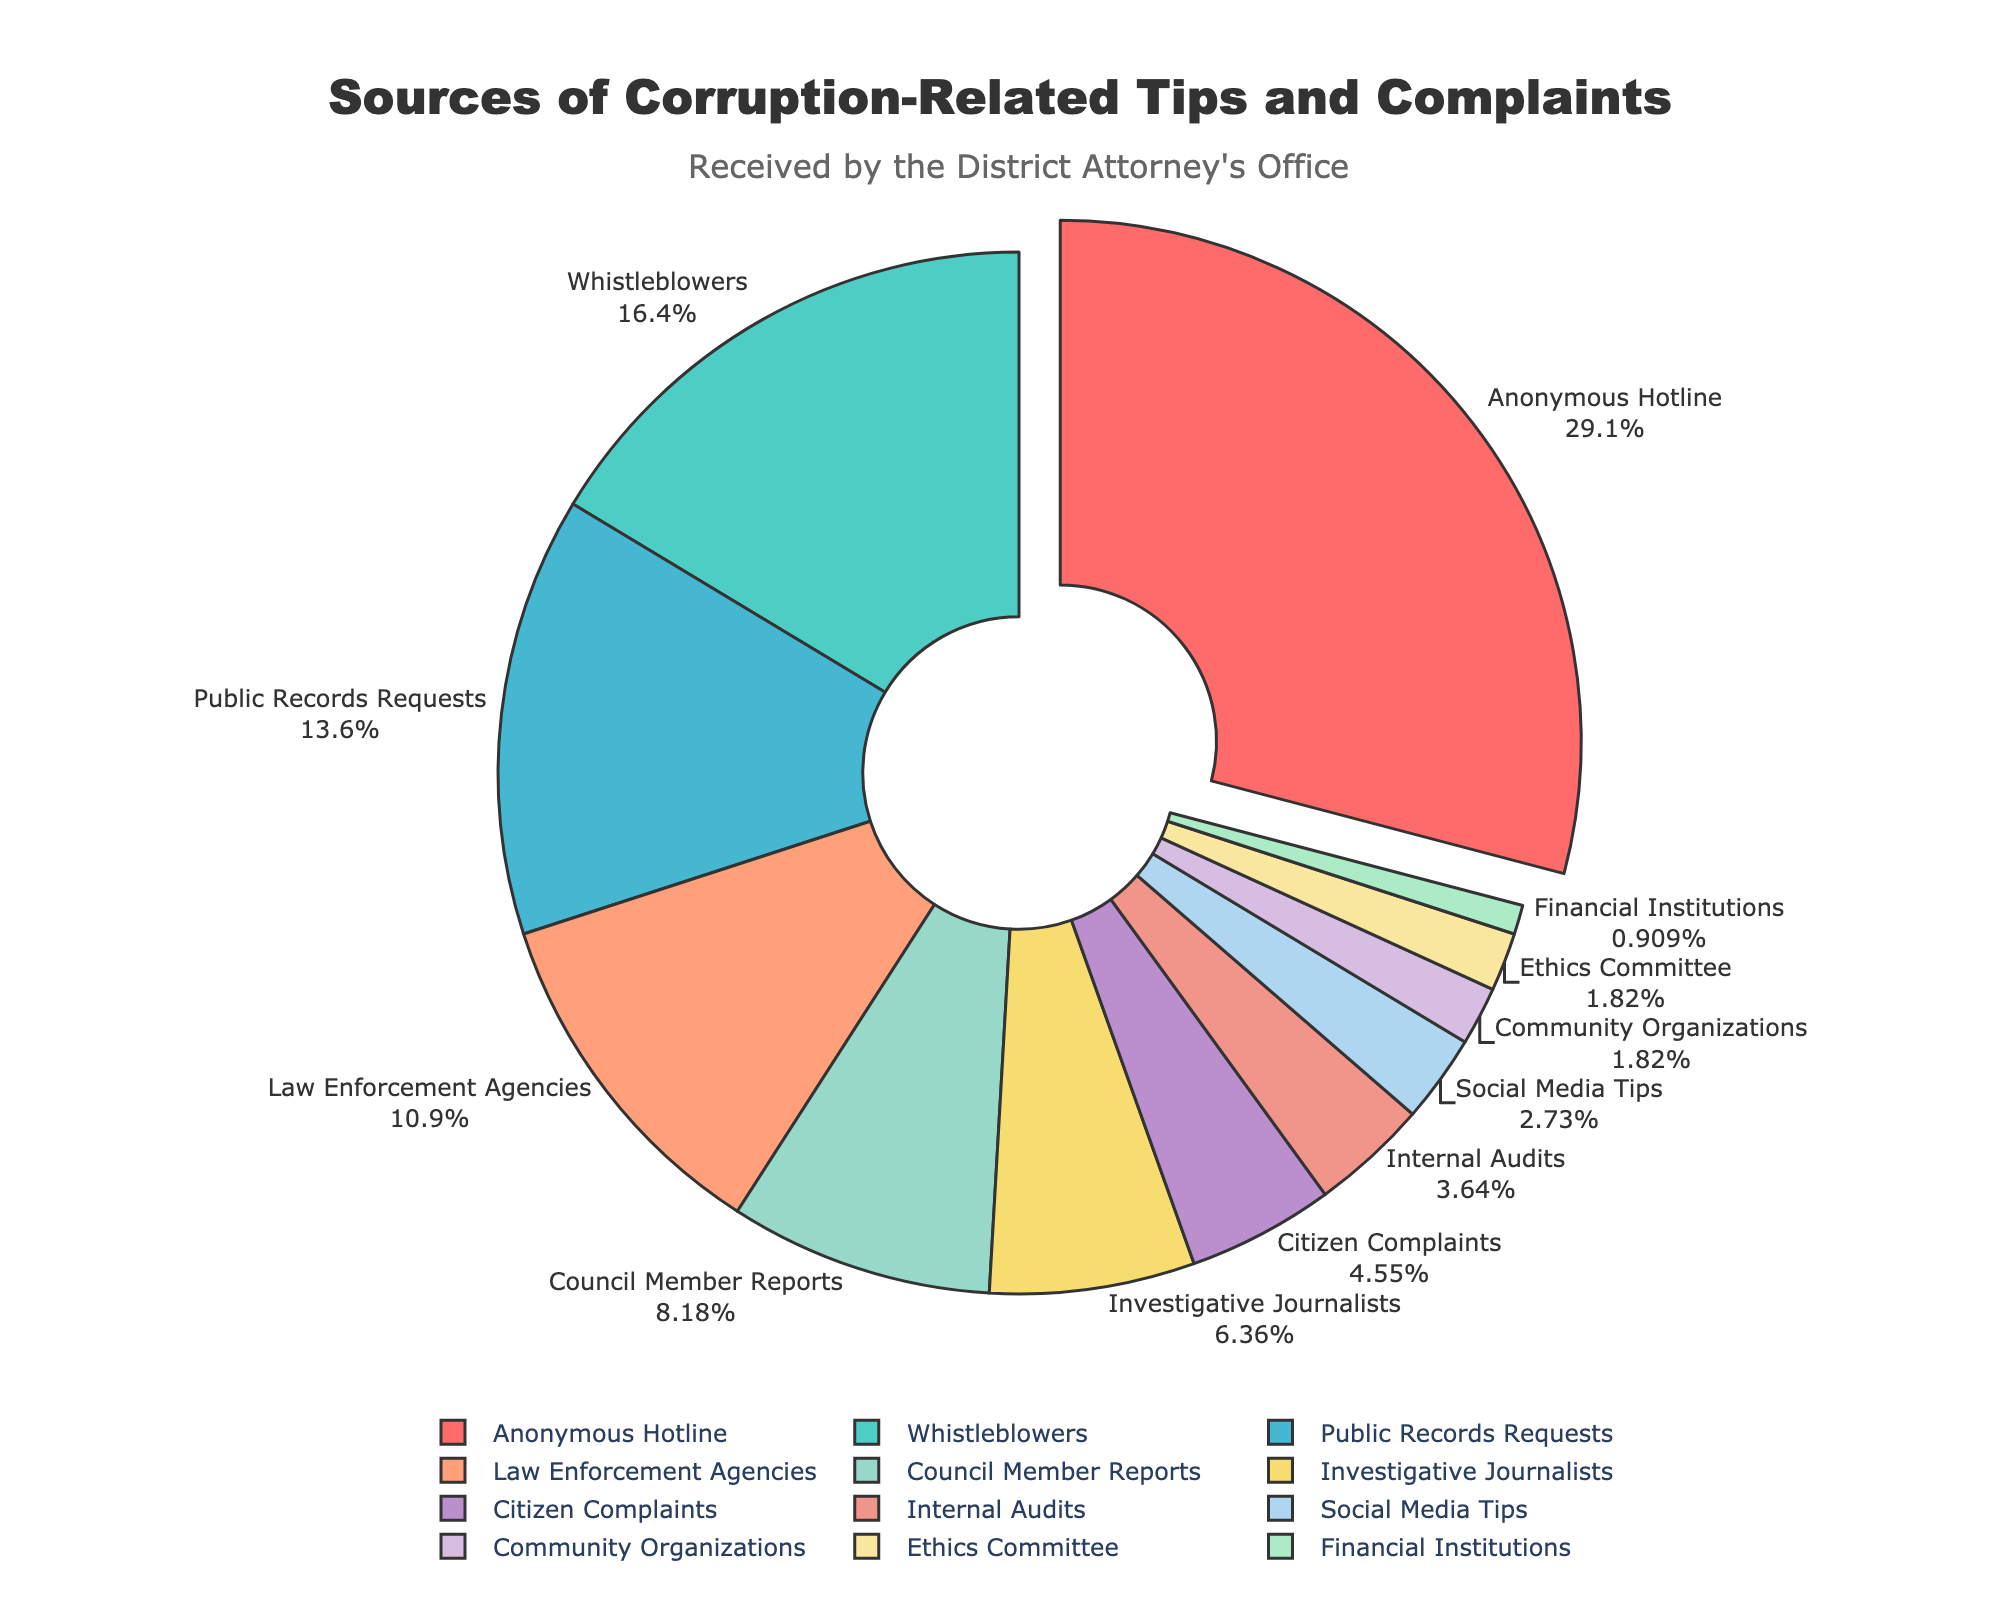Which source contributes the highest percentage of corruption-related tips and complaints? The "Anonymous Hotline" section is visually distinct because it is the largest slice in the pie and is slightly pulled out. This indicates that it has the highest percentage.
Answer: Anonymous Hotline Compare the percentages of tips received from Whistleblowers and Law Enforcement Agencies. Which is higher? The pie chart shows that Whistleblowers contribute 18% while Law Enforcement Agencies contribute 12%. Therefore, Whistleblowers are higher.
Answer: Whistleblowers What is the combined percentage of tips received from Citizen Complaints, Social Media Tips, Community Organizations, Ethics Committee, and Financial Institutions? Adding the percentages of these categories: 5% (Citizen Complaints) + 3% (Social Media Tips) + 2% (Community Organizations) + 2% (Ethics Committee) + 1% (Financial Institutions) = 13%.
Answer: 13% Which sources, when combined, provide less than 10% of the tips and complaints? The sources that individually contribute less than 10% and whose combined contribution is also less than 10% are Community Organizations (2%), Ethics Committee (2%), and Financial Institutions (1%). Adding these gives 2% + 2% + 1% = 5%.
Answer: Community Organizations, Ethics Committee, Financial Institutions Is the percentage of tips from Council Member Reports greater than the percentage from Investigative Journalists? The pie chart shows that Council Member Reports contribute 9%, while Investigative Journalists contribute 7%. Therefore, Council Member Reports is higher.
Answer: Yes Which categories of sources have a combined total that surpasses that of the largest single source? The largest single source is Anonymous Hotline at 32%. Combining Whistleblowers (18%) and Public Records Requests (15%) gives 18% + 15% = 33%, which surpasses 32%.
Answer: Whistleblowers, Public Records Requests What percentage of tips and complaints are received from sources involving some form of media? Social Media Tips contribute 3%, and Investigative Journalists contribute 7%. Adding these gives 3% + 7% = 10%.
Answer: 10% Identify two sources with the closest percentage of tips and complaints received and state their combined percentage. Community Organizations and Ethics Committee both contribute 2%. Their combined percentage is 2% + 2% = 4%.
Answer: 4% By how much does the percentage of tips from Whistleblowers exceed those from Internal Audits? Whistleblowers account for 18% while Internal Audits contribute 4%. The difference is 18% - 4% = 14%.
Answer: 14% 